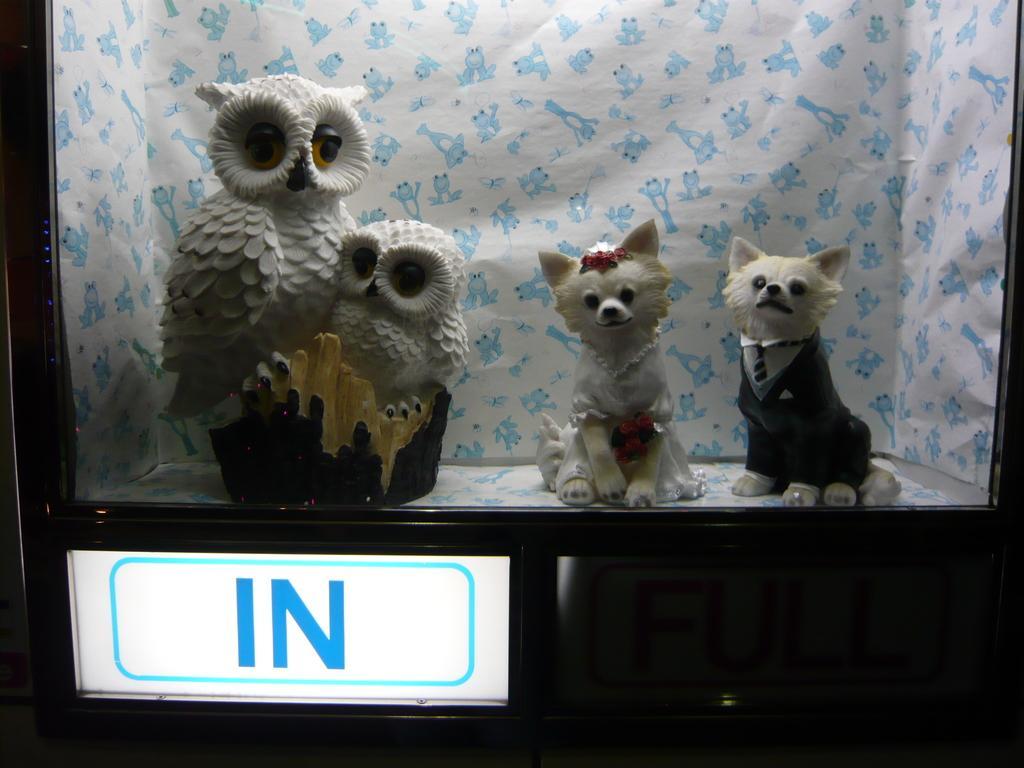Could you give a brief overview of what you see in this image? In this picture we can see toys placed on a platform, board and in the background we can see a cloth. 